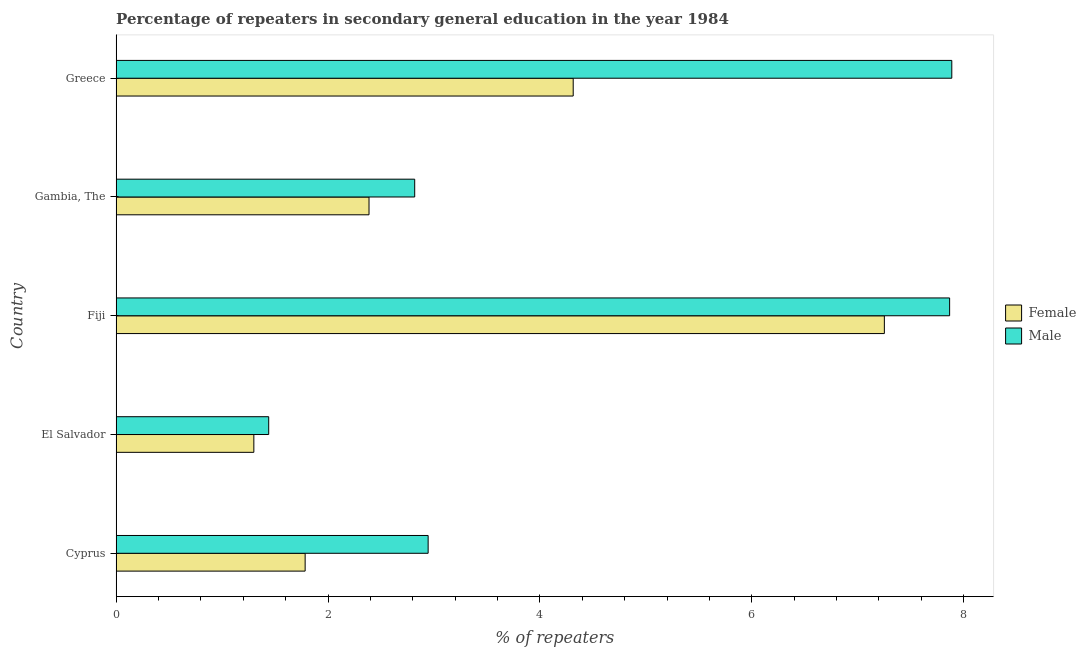Are the number of bars per tick equal to the number of legend labels?
Ensure brevity in your answer.  Yes. How many bars are there on the 2nd tick from the top?
Your answer should be compact. 2. How many bars are there on the 3rd tick from the bottom?
Provide a short and direct response. 2. What is the label of the 2nd group of bars from the top?
Provide a short and direct response. Gambia, The. In how many cases, is the number of bars for a given country not equal to the number of legend labels?
Your answer should be very brief. 0. What is the percentage of female repeaters in El Salvador?
Provide a short and direct response. 1.3. Across all countries, what is the maximum percentage of male repeaters?
Keep it short and to the point. 7.89. Across all countries, what is the minimum percentage of male repeaters?
Make the answer very short. 1.44. In which country was the percentage of female repeaters minimum?
Ensure brevity in your answer.  El Salvador. What is the total percentage of female repeaters in the graph?
Provide a short and direct response. 17.04. What is the difference between the percentage of female repeaters in Gambia, The and that in Greece?
Keep it short and to the point. -1.93. What is the difference between the percentage of male repeaters in Gambia, The and the percentage of female repeaters in Cyprus?
Make the answer very short. 1.03. What is the average percentage of female repeaters per country?
Give a very brief answer. 3.41. What is the difference between the percentage of male repeaters and percentage of female repeaters in Fiji?
Ensure brevity in your answer.  0.62. In how many countries, is the percentage of female repeaters greater than 6 %?
Offer a terse response. 1. What is the ratio of the percentage of male repeaters in El Salvador to that in Greece?
Keep it short and to the point. 0.18. Is the difference between the percentage of male repeaters in Cyprus and Fiji greater than the difference between the percentage of female repeaters in Cyprus and Fiji?
Offer a very short reply. Yes. What is the difference between the highest and the second highest percentage of male repeaters?
Provide a succinct answer. 0.02. What is the difference between the highest and the lowest percentage of female repeaters?
Offer a terse response. 5.95. In how many countries, is the percentage of male repeaters greater than the average percentage of male repeaters taken over all countries?
Provide a short and direct response. 2. What does the 2nd bar from the top in El Salvador represents?
Your answer should be very brief. Female. What does the 1st bar from the bottom in Gambia, The represents?
Provide a short and direct response. Female. How many bars are there?
Provide a short and direct response. 10. Does the graph contain grids?
Provide a short and direct response. No. How are the legend labels stacked?
Your answer should be very brief. Vertical. What is the title of the graph?
Your answer should be very brief. Percentage of repeaters in secondary general education in the year 1984. Does "Age 65(female)" appear as one of the legend labels in the graph?
Give a very brief answer. No. What is the label or title of the X-axis?
Ensure brevity in your answer.  % of repeaters. What is the label or title of the Y-axis?
Offer a terse response. Country. What is the % of repeaters of Female in Cyprus?
Offer a very short reply. 1.78. What is the % of repeaters in Male in Cyprus?
Your answer should be very brief. 2.94. What is the % of repeaters of Female in El Salvador?
Offer a terse response. 1.3. What is the % of repeaters in Male in El Salvador?
Provide a short and direct response. 1.44. What is the % of repeaters in Female in Fiji?
Ensure brevity in your answer.  7.25. What is the % of repeaters in Male in Fiji?
Provide a short and direct response. 7.87. What is the % of repeaters of Female in Gambia, The?
Provide a succinct answer. 2.39. What is the % of repeaters in Male in Gambia, The?
Your answer should be very brief. 2.82. What is the % of repeaters of Female in Greece?
Provide a short and direct response. 4.31. What is the % of repeaters in Male in Greece?
Make the answer very short. 7.89. Across all countries, what is the maximum % of repeaters of Female?
Provide a succinct answer. 7.25. Across all countries, what is the maximum % of repeaters in Male?
Your answer should be compact. 7.89. Across all countries, what is the minimum % of repeaters of Female?
Provide a succinct answer. 1.3. Across all countries, what is the minimum % of repeaters of Male?
Your answer should be very brief. 1.44. What is the total % of repeaters of Female in the graph?
Ensure brevity in your answer.  17.04. What is the total % of repeaters of Male in the graph?
Offer a terse response. 22.96. What is the difference between the % of repeaters in Female in Cyprus and that in El Salvador?
Your response must be concise. 0.48. What is the difference between the % of repeaters in Male in Cyprus and that in El Salvador?
Offer a very short reply. 1.5. What is the difference between the % of repeaters in Female in Cyprus and that in Fiji?
Your response must be concise. -5.47. What is the difference between the % of repeaters of Male in Cyprus and that in Fiji?
Keep it short and to the point. -4.92. What is the difference between the % of repeaters in Female in Cyprus and that in Gambia, The?
Provide a succinct answer. -0.6. What is the difference between the % of repeaters in Male in Cyprus and that in Gambia, The?
Your response must be concise. 0.13. What is the difference between the % of repeaters in Female in Cyprus and that in Greece?
Make the answer very short. -2.53. What is the difference between the % of repeaters of Male in Cyprus and that in Greece?
Give a very brief answer. -4.94. What is the difference between the % of repeaters in Female in El Salvador and that in Fiji?
Keep it short and to the point. -5.95. What is the difference between the % of repeaters in Male in El Salvador and that in Fiji?
Give a very brief answer. -6.43. What is the difference between the % of repeaters in Female in El Salvador and that in Gambia, The?
Your answer should be very brief. -1.09. What is the difference between the % of repeaters of Male in El Salvador and that in Gambia, The?
Your answer should be very brief. -1.38. What is the difference between the % of repeaters of Female in El Salvador and that in Greece?
Your answer should be very brief. -3.01. What is the difference between the % of repeaters in Male in El Salvador and that in Greece?
Your response must be concise. -6.45. What is the difference between the % of repeaters in Female in Fiji and that in Gambia, The?
Provide a short and direct response. 4.86. What is the difference between the % of repeaters of Male in Fiji and that in Gambia, The?
Ensure brevity in your answer.  5.05. What is the difference between the % of repeaters in Female in Fiji and that in Greece?
Keep it short and to the point. 2.94. What is the difference between the % of repeaters in Male in Fiji and that in Greece?
Make the answer very short. -0.02. What is the difference between the % of repeaters in Female in Gambia, The and that in Greece?
Your answer should be very brief. -1.93. What is the difference between the % of repeaters in Male in Gambia, The and that in Greece?
Your response must be concise. -5.07. What is the difference between the % of repeaters of Female in Cyprus and the % of repeaters of Male in El Salvador?
Your answer should be compact. 0.34. What is the difference between the % of repeaters in Female in Cyprus and the % of repeaters in Male in Fiji?
Make the answer very short. -6.08. What is the difference between the % of repeaters of Female in Cyprus and the % of repeaters of Male in Gambia, The?
Your answer should be compact. -1.03. What is the difference between the % of repeaters in Female in Cyprus and the % of repeaters in Male in Greece?
Provide a short and direct response. -6.1. What is the difference between the % of repeaters in Female in El Salvador and the % of repeaters in Male in Fiji?
Make the answer very short. -6.57. What is the difference between the % of repeaters in Female in El Salvador and the % of repeaters in Male in Gambia, The?
Offer a terse response. -1.52. What is the difference between the % of repeaters in Female in El Salvador and the % of repeaters in Male in Greece?
Keep it short and to the point. -6.59. What is the difference between the % of repeaters of Female in Fiji and the % of repeaters of Male in Gambia, The?
Offer a very short reply. 4.43. What is the difference between the % of repeaters in Female in Fiji and the % of repeaters in Male in Greece?
Provide a succinct answer. -0.64. What is the difference between the % of repeaters in Female in Gambia, The and the % of repeaters in Male in Greece?
Your answer should be very brief. -5.5. What is the average % of repeaters in Female per country?
Offer a terse response. 3.41. What is the average % of repeaters in Male per country?
Offer a terse response. 4.59. What is the difference between the % of repeaters in Female and % of repeaters in Male in Cyprus?
Keep it short and to the point. -1.16. What is the difference between the % of repeaters of Female and % of repeaters of Male in El Salvador?
Your answer should be compact. -0.14. What is the difference between the % of repeaters of Female and % of repeaters of Male in Fiji?
Provide a short and direct response. -0.62. What is the difference between the % of repeaters of Female and % of repeaters of Male in Gambia, The?
Your response must be concise. -0.43. What is the difference between the % of repeaters in Female and % of repeaters in Male in Greece?
Your response must be concise. -3.57. What is the ratio of the % of repeaters of Female in Cyprus to that in El Salvador?
Your answer should be very brief. 1.37. What is the ratio of the % of repeaters of Male in Cyprus to that in El Salvador?
Make the answer very short. 2.04. What is the ratio of the % of repeaters of Female in Cyprus to that in Fiji?
Your answer should be compact. 0.25. What is the ratio of the % of repeaters in Male in Cyprus to that in Fiji?
Your response must be concise. 0.37. What is the ratio of the % of repeaters in Female in Cyprus to that in Gambia, The?
Offer a terse response. 0.75. What is the ratio of the % of repeaters of Male in Cyprus to that in Gambia, The?
Make the answer very short. 1.04. What is the ratio of the % of repeaters in Female in Cyprus to that in Greece?
Make the answer very short. 0.41. What is the ratio of the % of repeaters in Male in Cyprus to that in Greece?
Provide a succinct answer. 0.37. What is the ratio of the % of repeaters in Female in El Salvador to that in Fiji?
Ensure brevity in your answer.  0.18. What is the ratio of the % of repeaters of Male in El Salvador to that in Fiji?
Your answer should be very brief. 0.18. What is the ratio of the % of repeaters of Female in El Salvador to that in Gambia, The?
Offer a terse response. 0.54. What is the ratio of the % of repeaters of Male in El Salvador to that in Gambia, The?
Offer a terse response. 0.51. What is the ratio of the % of repeaters of Female in El Salvador to that in Greece?
Offer a terse response. 0.3. What is the ratio of the % of repeaters in Male in El Salvador to that in Greece?
Make the answer very short. 0.18. What is the ratio of the % of repeaters in Female in Fiji to that in Gambia, The?
Keep it short and to the point. 3.04. What is the ratio of the % of repeaters in Male in Fiji to that in Gambia, The?
Provide a succinct answer. 2.79. What is the ratio of the % of repeaters of Female in Fiji to that in Greece?
Provide a short and direct response. 1.68. What is the ratio of the % of repeaters in Male in Fiji to that in Greece?
Provide a short and direct response. 1. What is the ratio of the % of repeaters in Female in Gambia, The to that in Greece?
Keep it short and to the point. 0.55. What is the ratio of the % of repeaters in Male in Gambia, The to that in Greece?
Your response must be concise. 0.36. What is the difference between the highest and the second highest % of repeaters of Female?
Your response must be concise. 2.94. What is the difference between the highest and the second highest % of repeaters in Male?
Offer a terse response. 0.02. What is the difference between the highest and the lowest % of repeaters in Female?
Your response must be concise. 5.95. What is the difference between the highest and the lowest % of repeaters of Male?
Make the answer very short. 6.45. 